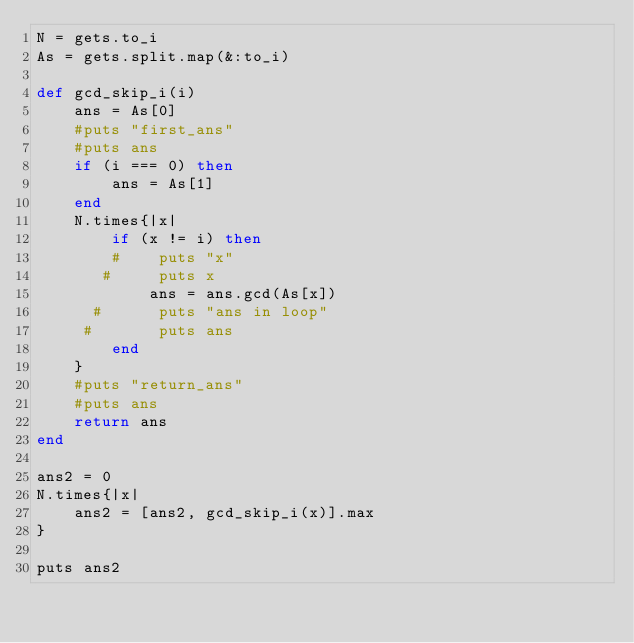<code> <loc_0><loc_0><loc_500><loc_500><_Ruby_>N = gets.to_i
As = gets.split.map(&:to_i)

def gcd_skip_i(i)
    ans = As[0]
    #puts "first_ans"
    #puts ans
    if (i === 0) then
        ans = As[1]
    end
    N.times{|x|
        if (x != i) then
        #    puts "x"
       #     puts x
            ans = ans.gcd(As[x])
      #      puts "ans in loop"
     #       puts ans
        end
    }
    #puts "return_ans"
    #puts ans
    return ans
end

ans2 = 0
N.times{|x|
    ans2 = [ans2, gcd_skip_i(x)].max
}

puts ans2
</code> 